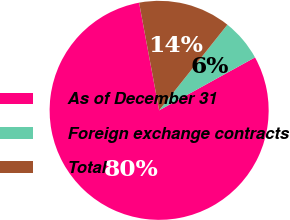Convert chart. <chart><loc_0><loc_0><loc_500><loc_500><pie_chart><fcel>As of December 31<fcel>Foreign exchange contracts<fcel>Total<nl><fcel>80.1%<fcel>6.26%<fcel>13.64%<nl></chart> 